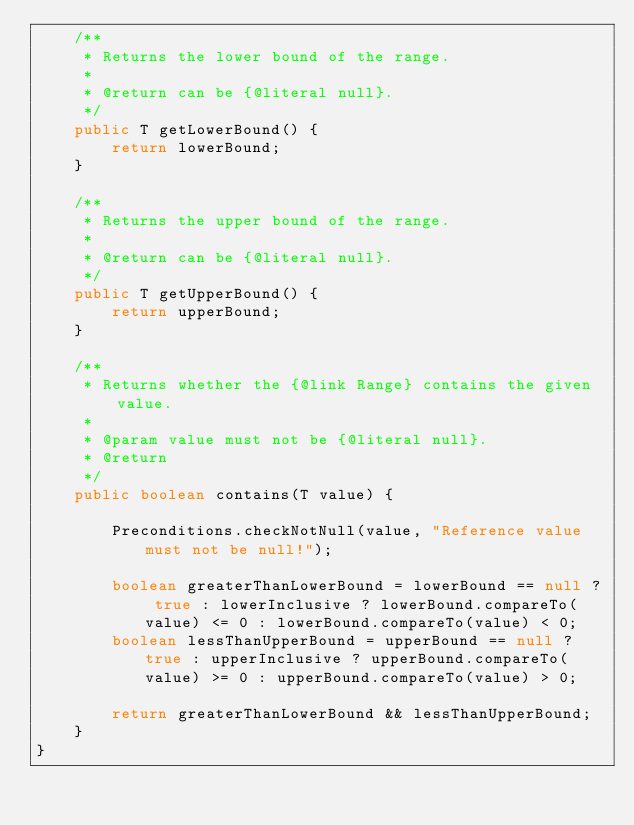Convert code to text. <code><loc_0><loc_0><loc_500><loc_500><_Java_>    /**
     * Returns the lower bound of the range.
     * 
     * @return can be {@literal null}.
     */
    public T getLowerBound() {
        return lowerBound;
    }

    /**
     * Returns the upper bound of the range.
     * 
     * @return can be {@literal null}.
     */
    public T getUpperBound() {
        return upperBound;
    }

    /**
     * Returns whether the {@link Range} contains the given value.
     * 
     * @param value must not be {@literal null}.
     * @return
     */
    public boolean contains(T value) {

        Preconditions.checkNotNull(value, "Reference value must not be null!");

        boolean greaterThanLowerBound = lowerBound == null ? true : lowerInclusive ? lowerBound.compareTo(value) <= 0 : lowerBound.compareTo(value) < 0;
        boolean lessThanUpperBound = upperBound == null ? true : upperInclusive ? upperBound.compareTo(value) >= 0 : upperBound.compareTo(value) > 0;

        return greaterThanLowerBound && lessThanUpperBound;
    }
}
</code> 